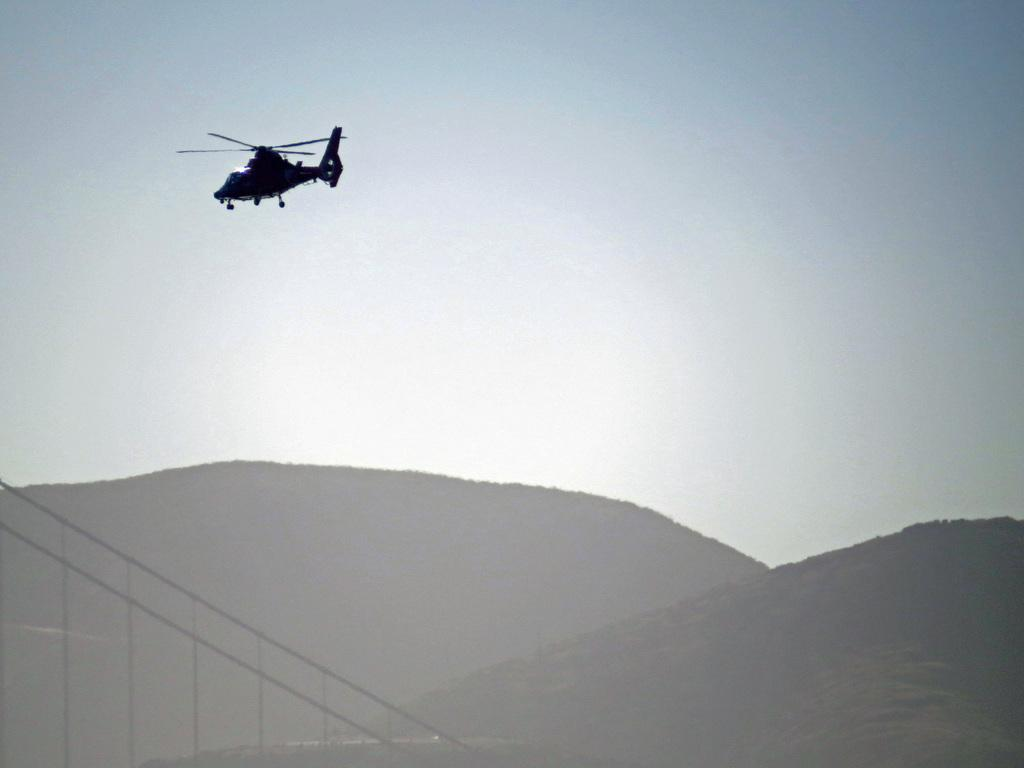What is flying in the sky in the image? There is a helicopter flying in the sky in the image. What type of structure can be seen in the image? There are ropes of a bridge visible in the image. What natural features are present in the image? There are hills in the image. How does the helicopter aid in the digestion process of the beetle in the image? There is no beetle present in the image, and the helicopter is not involved in any digestion process. 